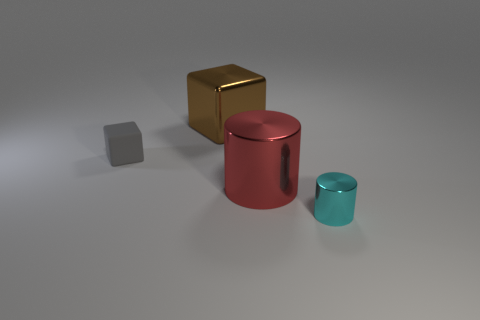Add 3 small metallic things. How many objects exist? 7 Subtract all yellow rubber cylinders. Subtract all large brown metal blocks. How many objects are left? 3 Add 1 cyan things. How many cyan things are left? 2 Add 4 small things. How many small things exist? 6 Subtract 1 red cylinders. How many objects are left? 3 